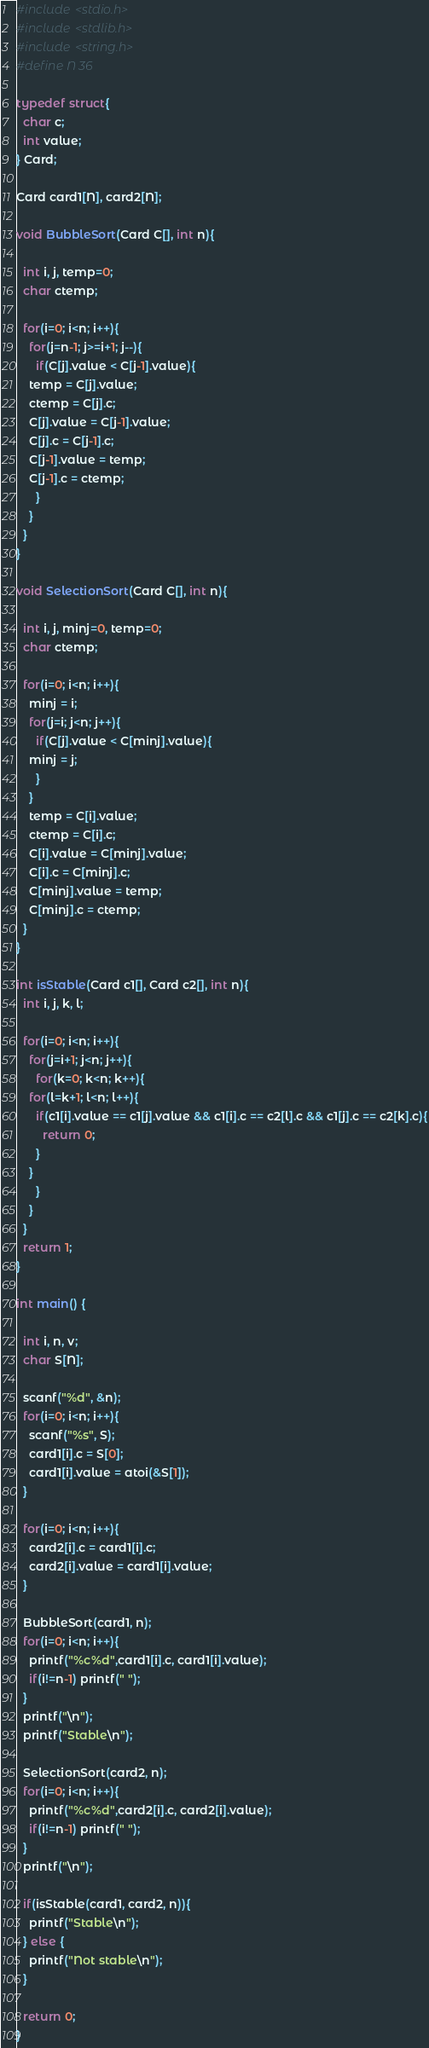<code> <loc_0><loc_0><loc_500><loc_500><_C_>#include <stdio.h>
#include <stdlib.h>
#include <string.h>
#define N 36

typedef struct{
  char c;
  int value;
} Card;

Card card1[N], card2[N];

void BubbleSort(Card C[], int n){

  int i, j, temp=0;
  char ctemp;
  
  for(i=0; i<n; i++){
    for(j=n-1; j>=i+1; j--){
      if(C[j].value < C[j-1].value){
	temp = C[j].value;
	ctemp = C[j].c;
	C[j].value = C[j-1].value;
	C[j].c = C[j-1].c;
	C[j-1].value = temp;
	C[j-1].c = ctemp;
      }
    }
  }
}

void SelectionSort(Card C[], int n){

  int i, j, minj=0, temp=0;
  char ctemp;

  for(i=0; i<n; i++){
    minj = i;
    for(j=i; j<n; j++){
      if(C[j].value < C[minj].value){
	minj = j;
      }
    }
    temp = C[i].value;
    ctemp = C[i].c;
    C[i].value = C[minj].value;
    C[i].c = C[minj].c;
    C[minj].value = temp;
    C[minj].c = ctemp;
  }
}

int isStable(Card c1[], Card c2[], int n){
  int i, j, k, l;

  for(i=0; i<n; i++){
    for(j=i+1; j<n; j++){
      for(k=0; k<n; k++){
	for(l=k+1; l<n; l++){
	  if(c1[i].value == c1[j].value && c1[i].c == c2[l].c && c1[j].c == c2[k].c){
	    return 0;
	  }
	}
      }
    }
  }
  return 1;
}

int main() {

  int i, n, v;
  char S[N];

  scanf("%d", &n);
  for(i=0; i<n; i++){
    scanf("%s", S);
    card1[i].c = S[0];
    card1[i].value = atoi(&S[1]);
  }

  for(i=0; i<n; i++){
    card2[i].c = card1[i].c;
    card2[i].value = card1[i].value;
  }

  BubbleSort(card1, n);
  for(i=0; i<n; i++){
    printf("%c%d",card1[i].c, card1[i].value);
    if(i!=n-1) printf(" ");
  }
  printf("\n");
  printf("Stable\n");

  SelectionSort(card2, n);
  for(i=0; i<n; i++){
    printf("%c%d",card2[i].c, card2[i].value);
    if(i!=n-1) printf(" ");
  }
  printf("\n");

  if(isStable(card1, card2, n)){
    printf("Stable\n");
  } else {
    printf("Not stable\n");
  }

  return 0;
}</code> 